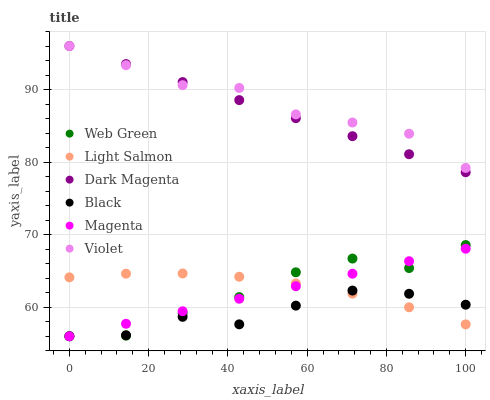Does Black have the minimum area under the curve?
Answer yes or no. Yes. Does Violet have the maximum area under the curve?
Answer yes or no. Yes. Does Dark Magenta have the minimum area under the curve?
Answer yes or no. No. Does Dark Magenta have the maximum area under the curve?
Answer yes or no. No. Is Magenta the smoothest?
Answer yes or no. Yes. Is Web Green the roughest?
Answer yes or no. Yes. Is Dark Magenta the smoothest?
Answer yes or no. No. Is Dark Magenta the roughest?
Answer yes or no. No. Does Web Green have the lowest value?
Answer yes or no. Yes. Does Dark Magenta have the lowest value?
Answer yes or no. No. Does Violet have the highest value?
Answer yes or no. Yes. Does Web Green have the highest value?
Answer yes or no. No. Is Light Salmon less than Dark Magenta?
Answer yes or no. Yes. Is Dark Magenta greater than Light Salmon?
Answer yes or no. Yes. Does Violet intersect Dark Magenta?
Answer yes or no. Yes. Is Violet less than Dark Magenta?
Answer yes or no. No. Is Violet greater than Dark Magenta?
Answer yes or no. No. Does Light Salmon intersect Dark Magenta?
Answer yes or no. No. 